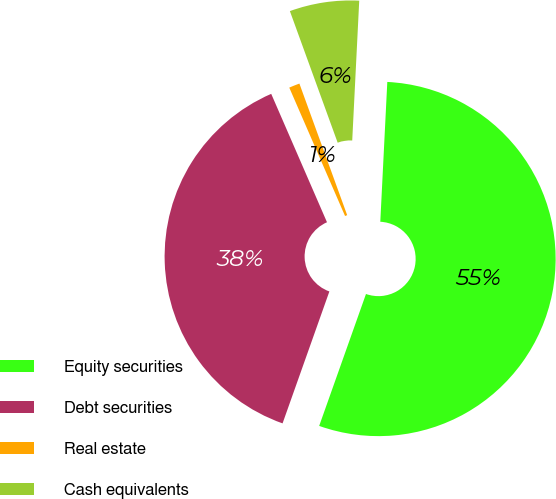<chart> <loc_0><loc_0><loc_500><loc_500><pie_chart><fcel>Equity securities<fcel>Debt securities<fcel>Real estate<fcel>Cash equivalents<nl><fcel>54.63%<fcel>38.05%<fcel>0.98%<fcel>6.34%<nl></chart> 